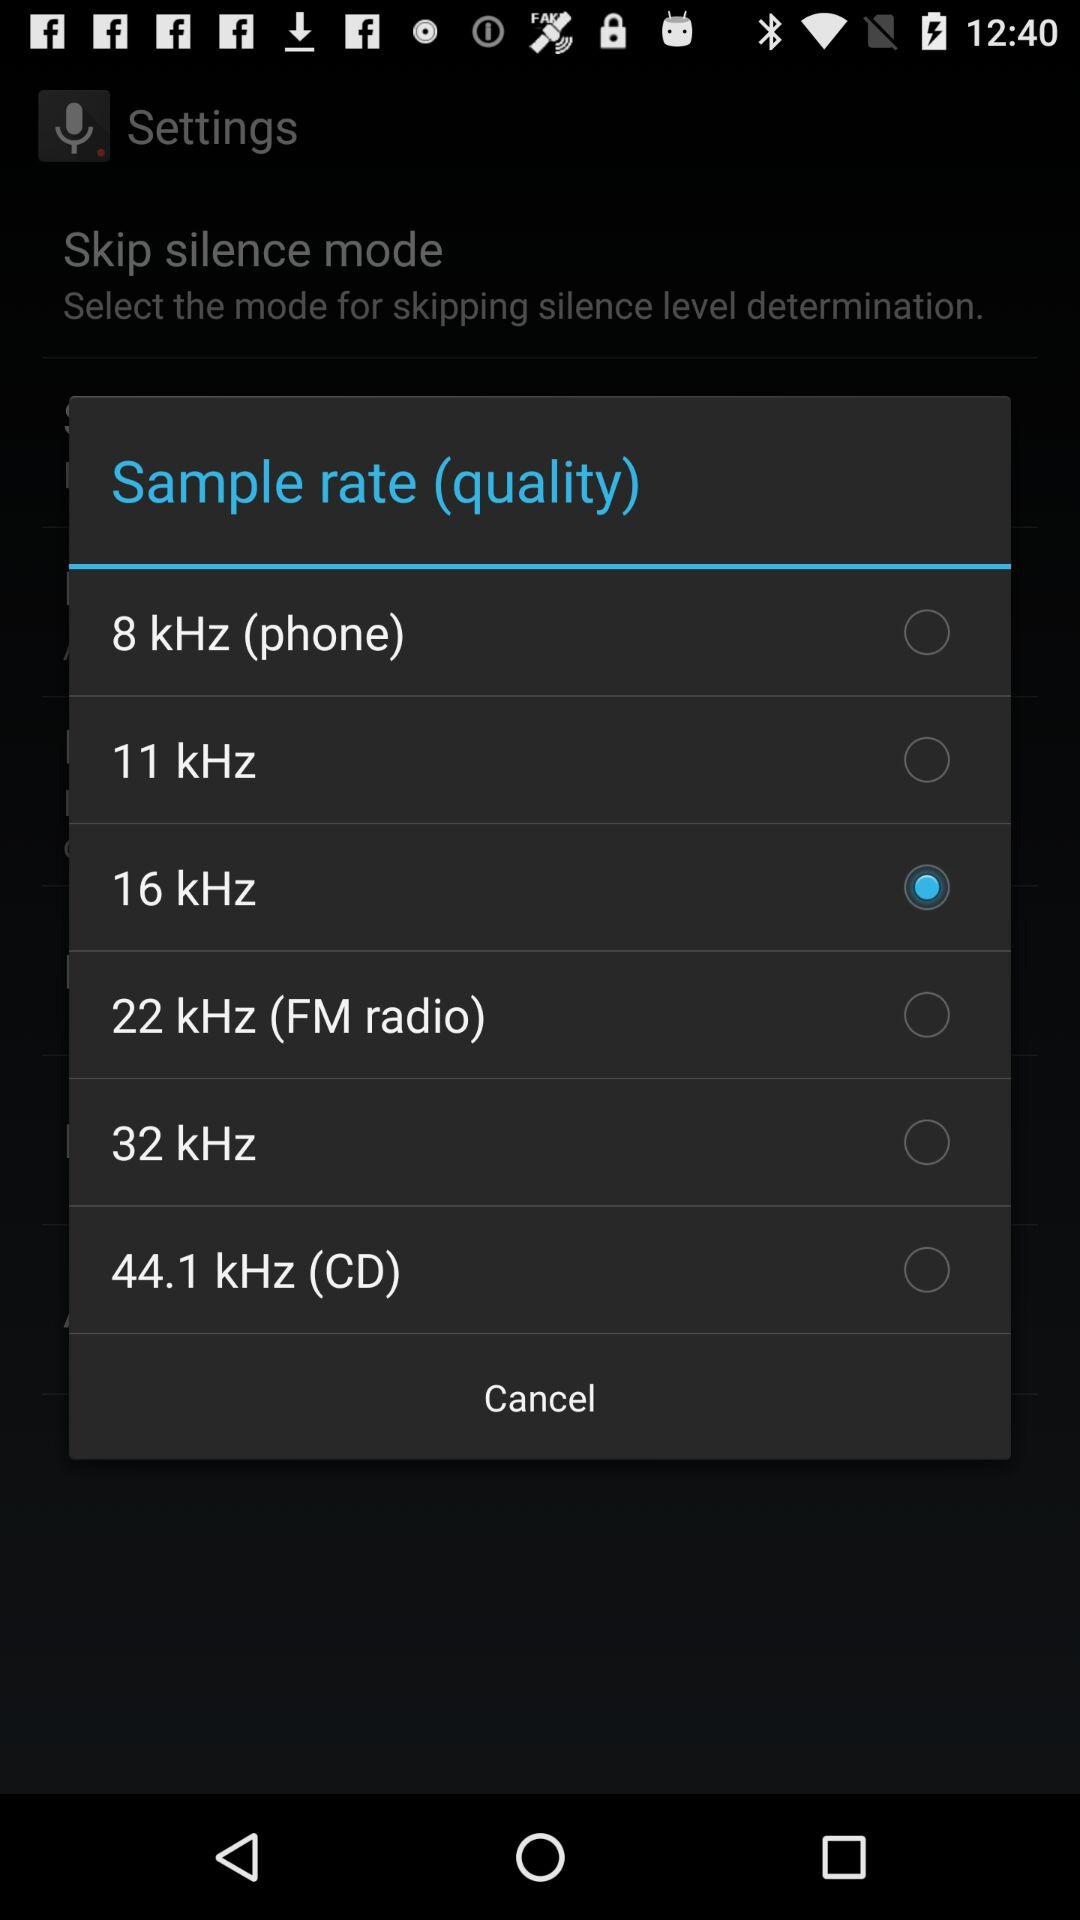How many sample rates are available?
Answer the question using a single word or phrase. 6 